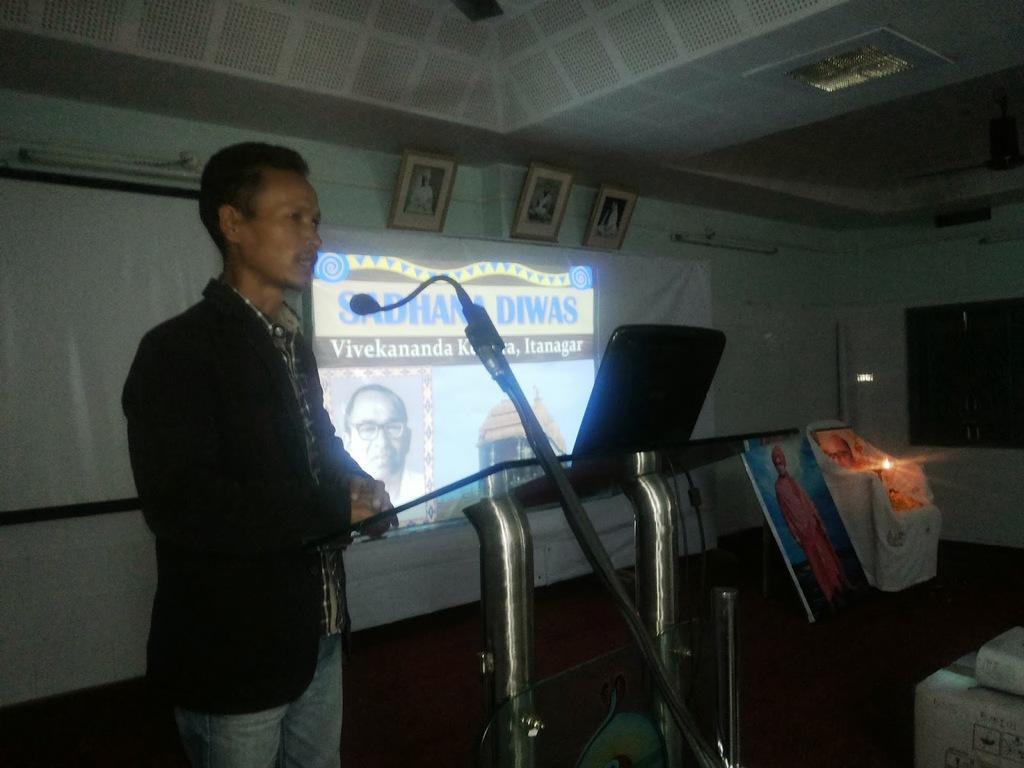Could you give a brief overview of what you see in this image? In this image, there is a person wearing clothes and standing in front of the mic. There is a screen and laptop in the middle of the image. There are photo frames on the right side of the image. 